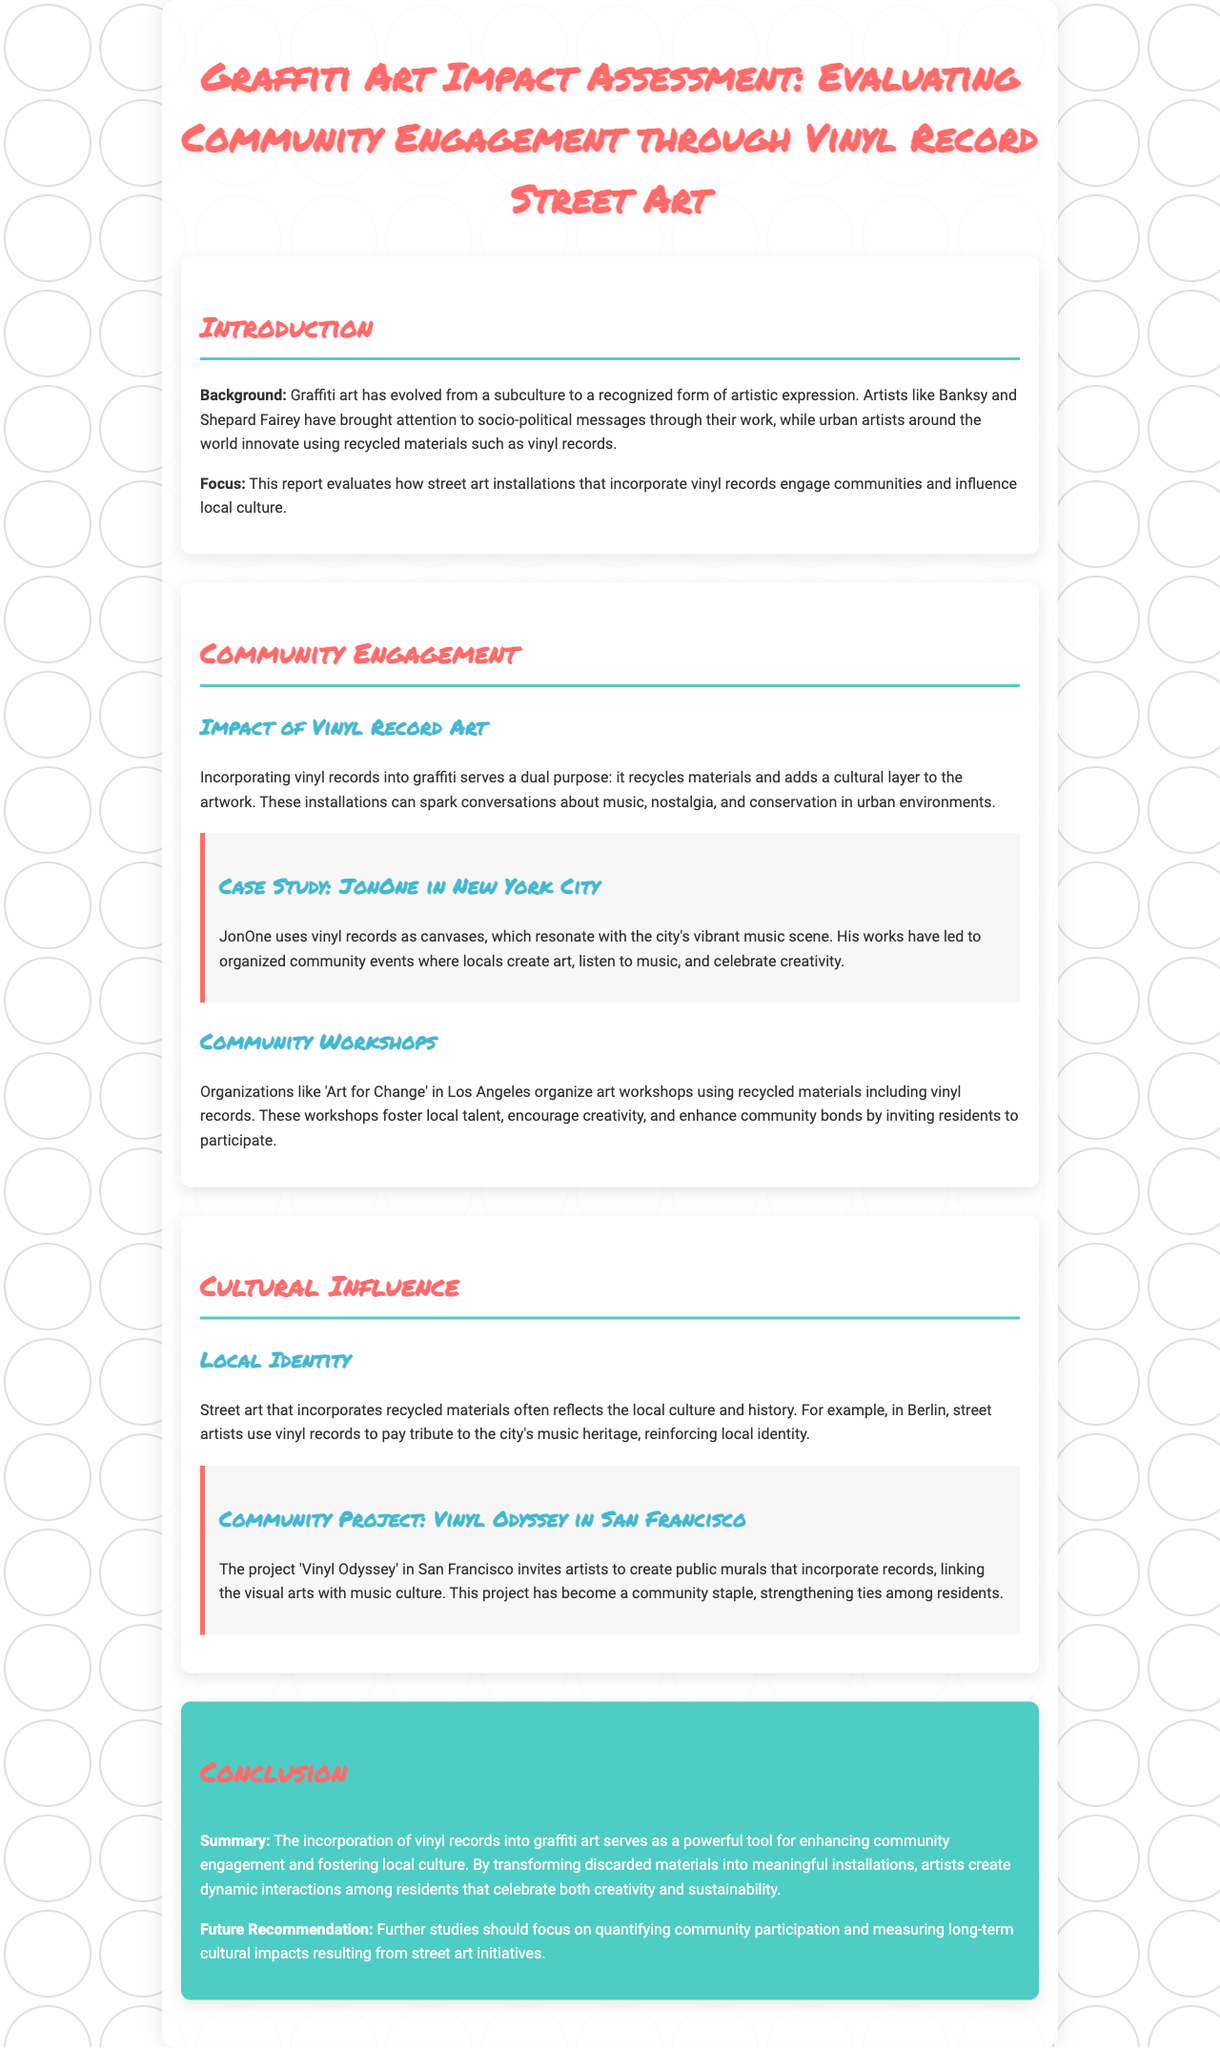What is the title of the report? The title of the report is listed prominently at the top, summarizing the focus of the assessment.
Answer: Graffiti Art Impact Assessment: Evaluating Community Engagement through Vinyl Record Street Art Who is the artist mentioned in the New York City case study? The case study discusses a specific artist noted for using vinyl records in his work within New York City's art scene.
Answer: JonOne What organization organizes workshops in Los Angeles? The report specifies an organization's name that organizes community art workshops, emphasizing their role in creative engagement.
Answer: Art for Change In which city is the 'Vinyl Odyssey' project located? The document identifies the specific city where the 'Vinyl Odyssey' community project is conducted, showcasing local engagement through vinyl art.
Answer: San Francisco What is a future recommendation made in the conclusion? The conclusion provides a specific focus for future studies, addressing the need for further understanding of sustinability in street art initiatives.
Answer: Quantifying community participation What type of materials are highlighted in the document as being used by artists? The report emphasizes the use of specific recycled materials that are creatively incorporated into street art installations.
Answer: Vinyl records What aspect of local culture do street artists reflect using vinyl records? The section discusses how street art contributes to cultural identity by reflecting the history specific to communities, especially through music.
Answer: Local identity How many case studies are presented in the document? The document contains multiple case studies that illustrate the impact of graffiti art in different cities, indicating the diversity of examples.
Answer: Two 